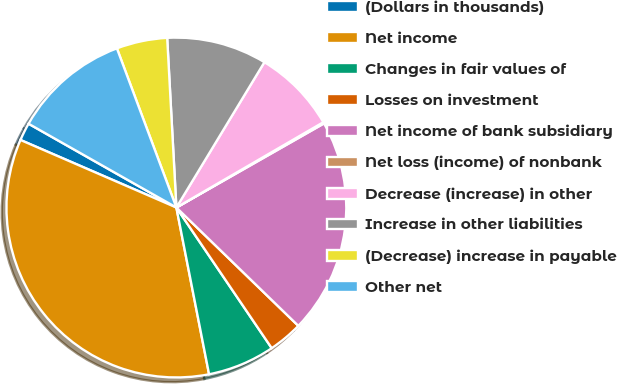Convert chart to OTSL. <chart><loc_0><loc_0><loc_500><loc_500><pie_chart><fcel>(Dollars in thousands)<fcel>Net income<fcel>Changes in fair values of<fcel>Losses on investment<fcel>Net income of bank subsidiary<fcel>Net loss (income) of nonbank<fcel>Decrease (increase) in other<fcel>Increase in other liabilities<fcel>(Decrease) increase in payable<fcel>Other net<nl><fcel>1.7%<fcel>34.59%<fcel>6.4%<fcel>3.26%<fcel>20.5%<fcel>0.13%<fcel>7.96%<fcel>9.53%<fcel>4.83%<fcel>11.1%<nl></chart> 